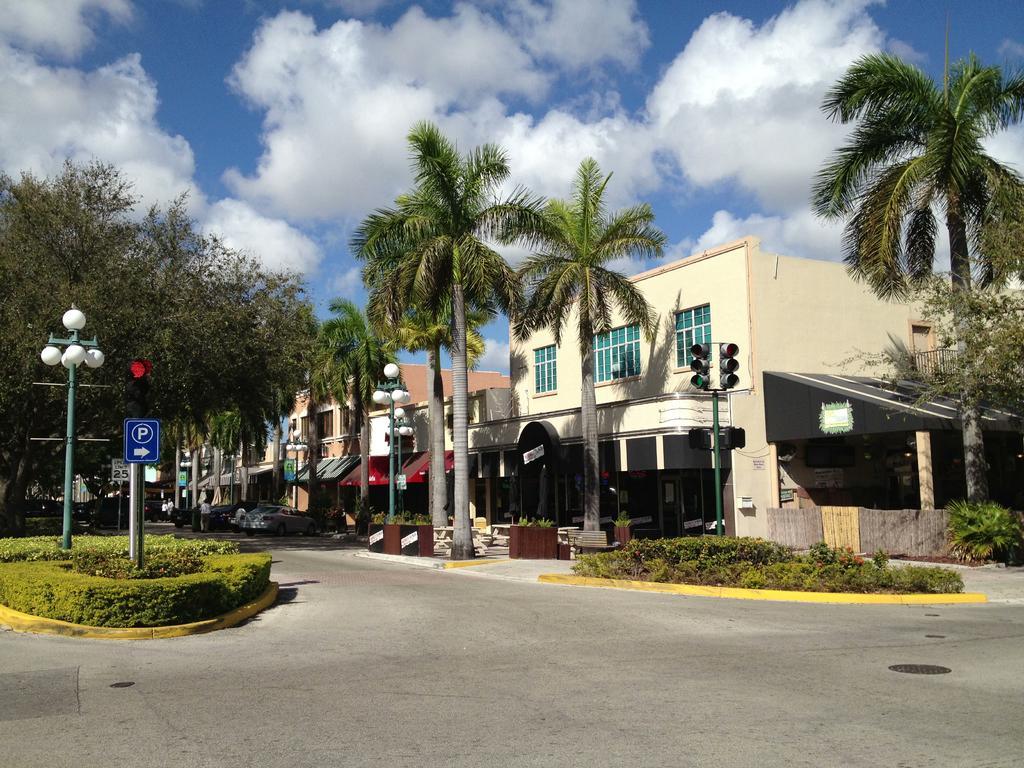Could you give a brief overview of what you see in this image? In this picture we can see few buildings, trees, poles and lights, on the left side of the image we can see a sign board, in the background we can see clouds. 